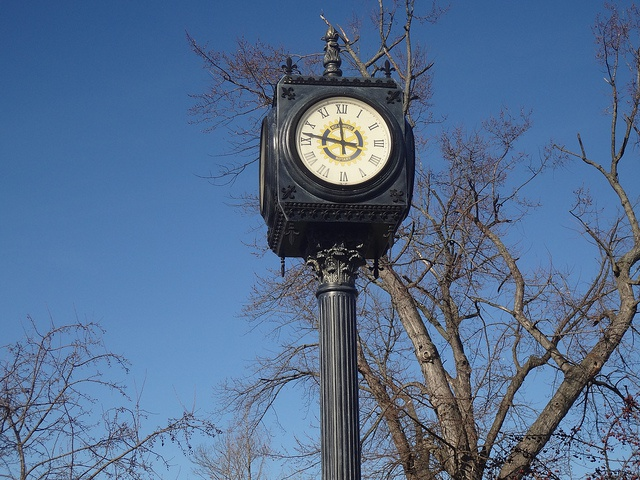Describe the objects in this image and their specific colors. I can see a clock in blue, beige, tan, black, and gray tones in this image. 